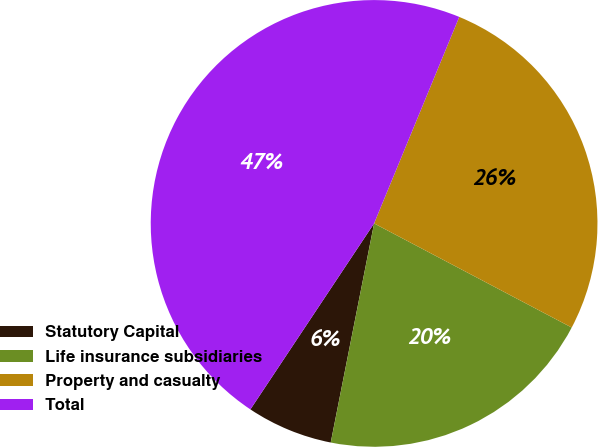Convert chart to OTSL. <chart><loc_0><loc_0><loc_500><loc_500><pie_chart><fcel>Statutory Capital<fcel>Life insurance subsidiaries<fcel>Property and casualty<fcel>Total<nl><fcel>6.23%<fcel>20.39%<fcel>26.49%<fcel>46.88%<nl></chart> 